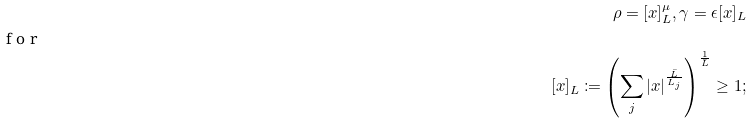<formula> <loc_0><loc_0><loc_500><loc_500>\rho = [ x ] _ { L } ^ { \mu } , \gamma = \epsilon [ x ] _ { L } \\ \shortintertext { f o r } [ x ] _ { L } \coloneqq \left ( \sum _ { j } | x | ^ { \frac { \bar { L } } { L _ { j } } } \right ) ^ { \frac { 1 } { \bar { L } } } \geq 1 ;</formula> 